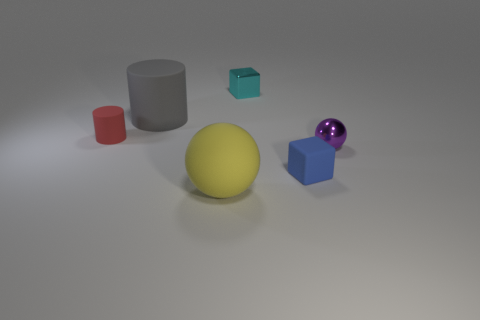Could you tell me about the lighting in this image? The lighting in the image is soft and diffused, coming from the upper left side, which creates gentle shadows on the right sides of the objects. The light source seems to be positioned above the scene, casting shadows on the matte ground plane, highlighting the shapes and textures of the objects. 